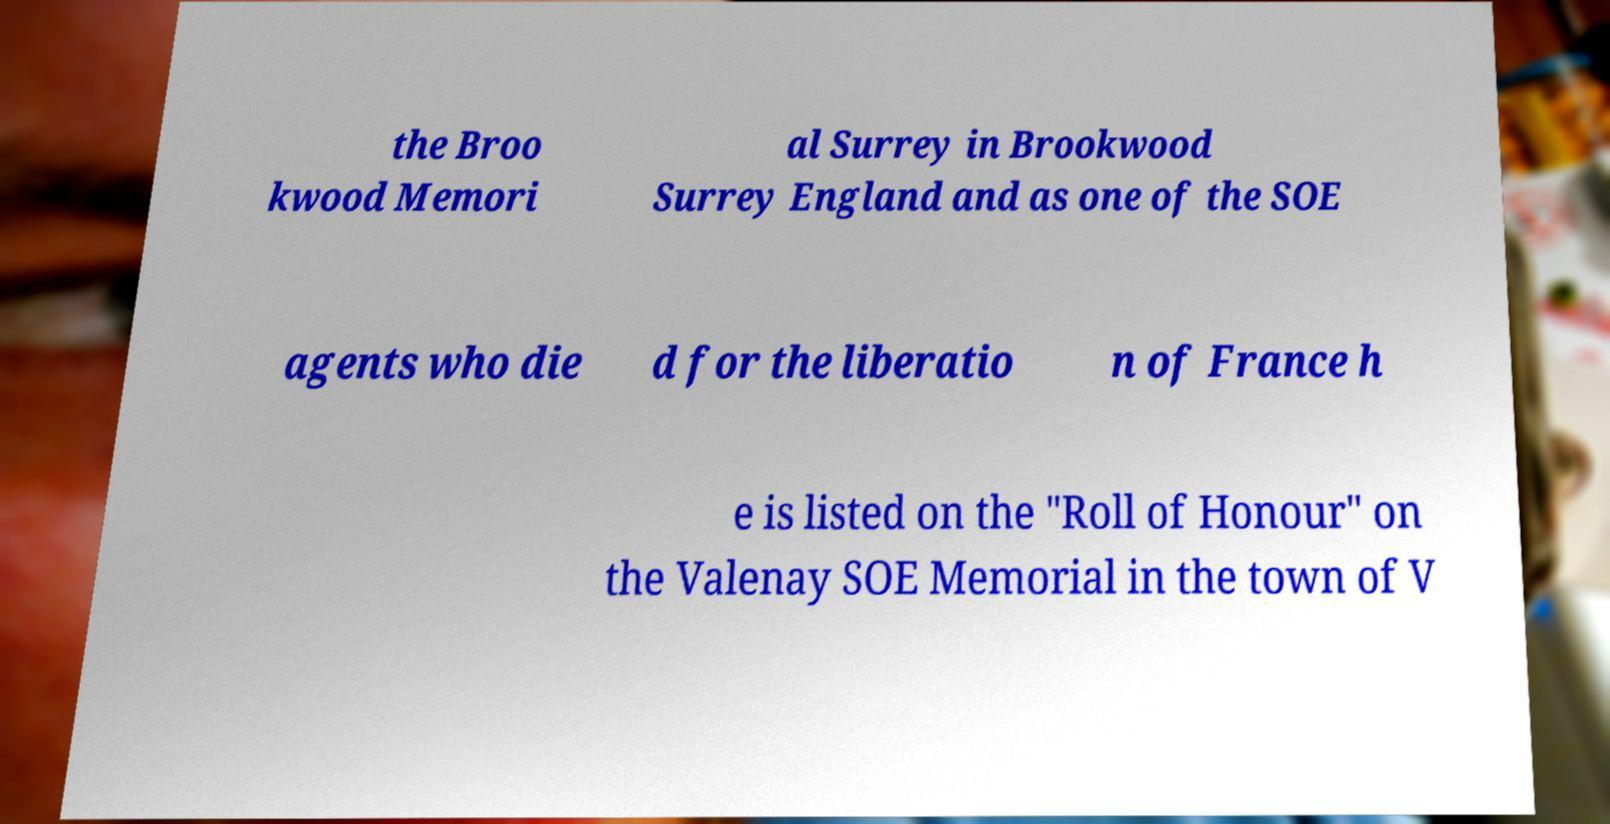There's text embedded in this image that I need extracted. Can you transcribe it verbatim? the Broo kwood Memori al Surrey in Brookwood Surrey England and as one of the SOE agents who die d for the liberatio n of France h e is listed on the "Roll of Honour" on the Valenay SOE Memorial in the town of V 